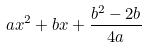Convert formula to latex. <formula><loc_0><loc_0><loc_500><loc_500>a x ^ { 2 } + b x + \frac { b ^ { 2 } - 2 b } { 4 a }</formula> 